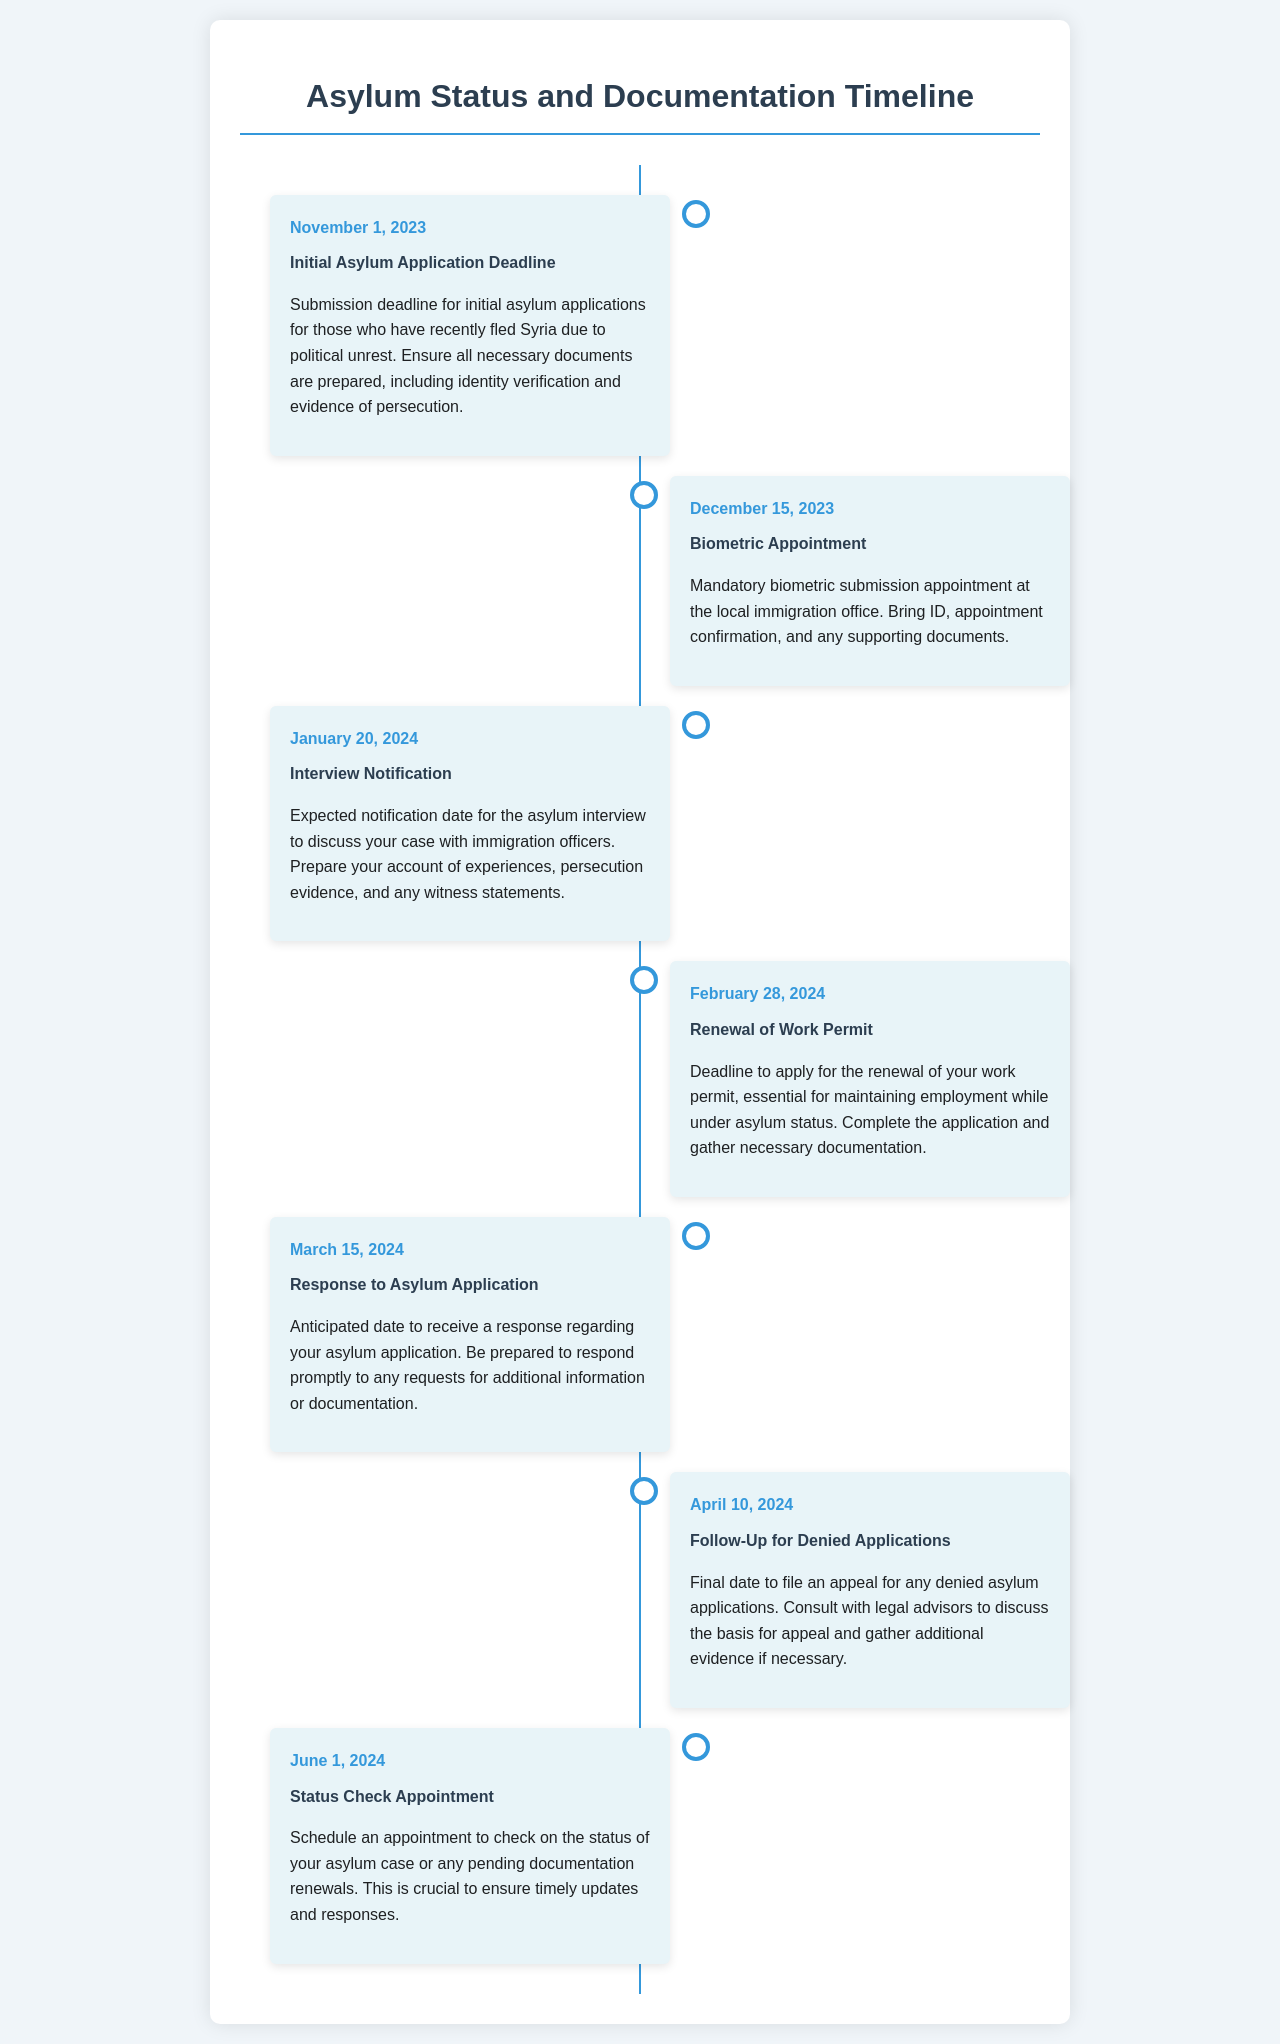what is the first important date listed? The first date in the timeline is for the initial asylum application deadline.
Answer: November 1, 2023 what is the purpose of the biometric appointment? The biometric appointment is mandatory for submitting biometric data at the local immigration office.
Answer: Mandatory biometric submission when is the expected date for the asylum interview notification? This date is provided in relation to when applicants can expect to be informed about their asylum interview.
Answer: January 20, 2024 what must be done by February 28, 2024? This date is relevant for the renewal of work permits under asylum status.
Answer: Renewal of Work Permit how should applicants prepare for the response to their asylum application? This preparation involves being ready to respond to any requests for additional information from immigration officers.
Answer: Prompt response what is the final date to file an appeal for denied applications? This information pertains specifically to the last opportunity for appeals in asylum applications.
Answer: April 10, 2024 what appointment should be scheduled by June 1, 2024? This date concerns checking the status of the asylum case or pending document renewals.
Answer: Status Check Appointment how are the events in the document structured? The events are organized in a timeline format with dates and descriptions.
Answer: Timeline format 